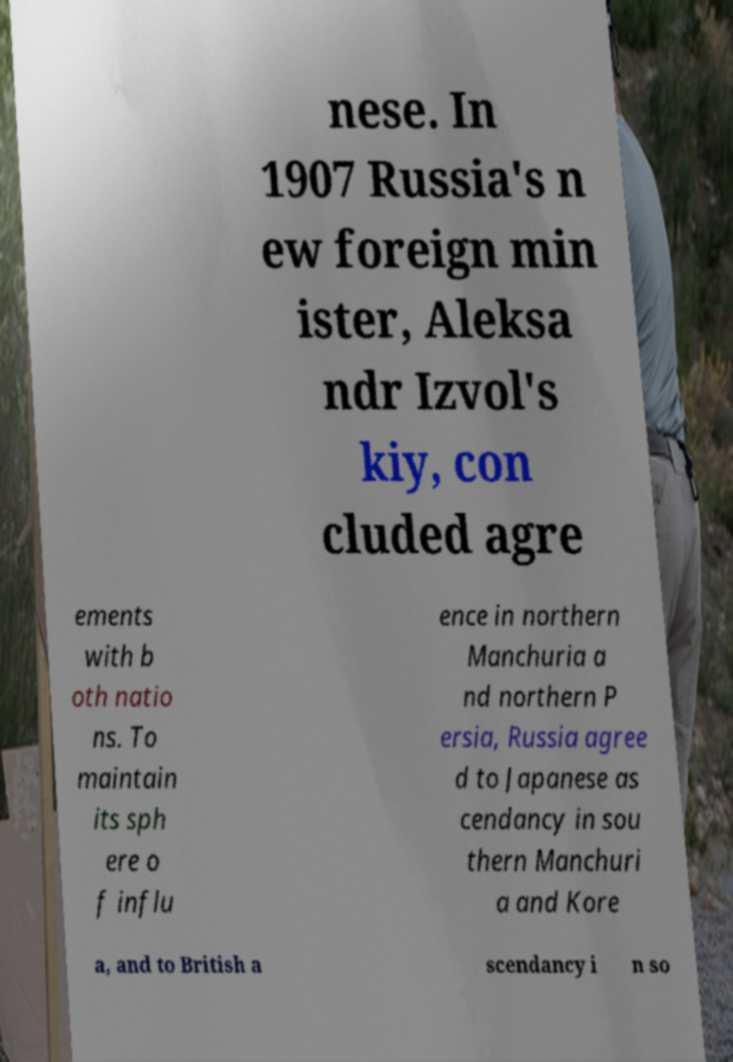Please read and relay the text visible in this image. What does it say? nese. In 1907 Russia's n ew foreign min ister, Aleksa ndr Izvol's kiy, con cluded agre ements with b oth natio ns. To maintain its sph ere o f influ ence in northern Manchuria a nd northern P ersia, Russia agree d to Japanese as cendancy in sou thern Manchuri a and Kore a, and to British a scendancy i n so 